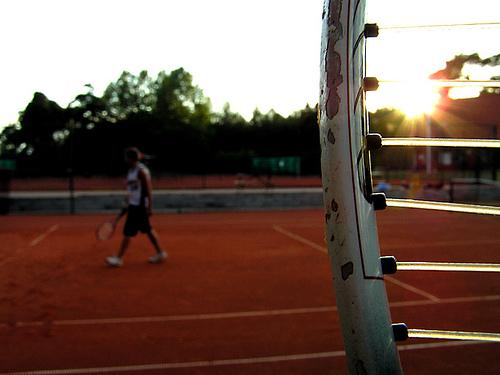What is partially blocking this image? racket 